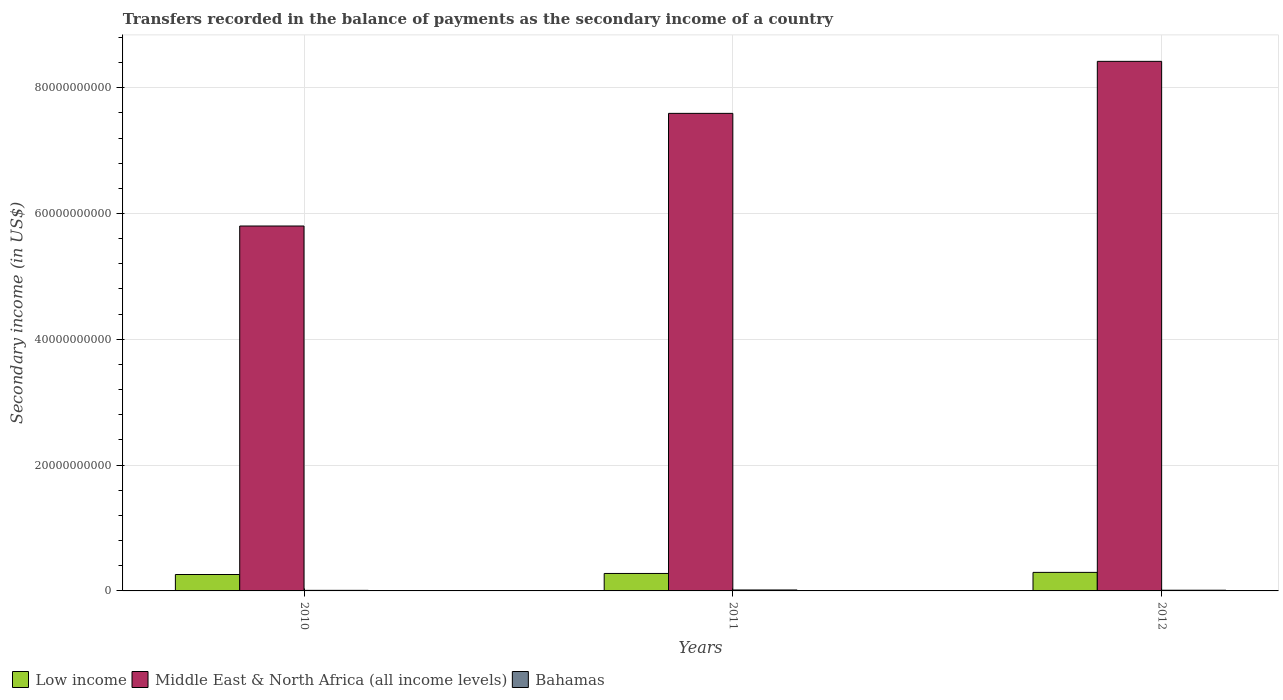How many different coloured bars are there?
Offer a very short reply. 3. Are the number of bars on each tick of the X-axis equal?
Make the answer very short. Yes. How many bars are there on the 3rd tick from the left?
Provide a succinct answer. 3. In how many cases, is the number of bars for a given year not equal to the number of legend labels?
Offer a very short reply. 0. What is the secondary income of in Low income in 2011?
Your answer should be compact. 2.78e+09. Across all years, what is the maximum secondary income of in Middle East & North Africa (all income levels)?
Provide a short and direct response. 8.42e+1. Across all years, what is the minimum secondary income of in Low income?
Your response must be concise. 2.61e+09. In which year was the secondary income of in Low income minimum?
Your answer should be compact. 2010. What is the total secondary income of in Low income in the graph?
Make the answer very short. 8.33e+09. What is the difference between the secondary income of in Low income in 2010 and that in 2011?
Your answer should be very brief. -1.67e+08. What is the difference between the secondary income of in Bahamas in 2011 and the secondary income of in Low income in 2010?
Offer a terse response. -2.46e+09. What is the average secondary income of in Bahamas per year?
Provide a short and direct response. 1.18e+08. In the year 2011, what is the difference between the secondary income of in Low income and secondary income of in Bahamas?
Offer a very short reply. 2.62e+09. In how many years, is the secondary income of in Middle East & North Africa (all income levels) greater than 60000000000 US$?
Make the answer very short. 2. What is the ratio of the secondary income of in Low income in 2011 to that in 2012?
Make the answer very short. 0.94. Is the difference between the secondary income of in Low income in 2010 and 2011 greater than the difference between the secondary income of in Bahamas in 2010 and 2011?
Ensure brevity in your answer.  No. What is the difference between the highest and the second highest secondary income of in Bahamas?
Provide a succinct answer. 3.89e+07. What is the difference between the highest and the lowest secondary income of in Middle East & North Africa (all income levels)?
Offer a terse response. 2.62e+1. Is the sum of the secondary income of in Middle East & North Africa (all income levels) in 2010 and 2011 greater than the maximum secondary income of in Bahamas across all years?
Your answer should be compact. Yes. What does the 1st bar from the right in 2010 represents?
Give a very brief answer. Bahamas. How many years are there in the graph?
Ensure brevity in your answer.  3. Are the values on the major ticks of Y-axis written in scientific E-notation?
Provide a short and direct response. No. What is the title of the graph?
Your answer should be compact. Transfers recorded in the balance of payments as the secondary income of a country. What is the label or title of the X-axis?
Your answer should be compact. Years. What is the label or title of the Y-axis?
Offer a very short reply. Secondary income (in US$). What is the Secondary income (in US$) of Low income in 2010?
Ensure brevity in your answer.  2.61e+09. What is the Secondary income (in US$) in Middle East & North Africa (all income levels) in 2010?
Keep it short and to the point. 5.80e+1. What is the Secondary income (in US$) of Bahamas in 2010?
Keep it short and to the point. 9.12e+07. What is the Secondary income (in US$) in Low income in 2011?
Provide a short and direct response. 2.78e+09. What is the Secondary income (in US$) of Middle East & North Africa (all income levels) in 2011?
Keep it short and to the point. 7.59e+1. What is the Secondary income (in US$) in Bahamas in 2011?
Ensure brevity in your answer.  1.50e+08. What is the Secondary income (in US$) of Low income in 2012?
Offer a very short reply. 2.95e+09. What is the Secondary income (in US$) of Middle East & North Africa (all income levels) in 2012?
Provide a succinct answer. 8.42e+1. What is the Secondary income (in US$) of Bahamas in 2012?
Provide a short and direct response. 1.11e+08. Across all years, what is the maximum Secondary income (in US$) of Low income?
Ensure brevity in your answer.  2.95e+09. Across all years, what is the maximum Secondary income (in US$) in Middle East & North Africa (all income levels)?
Offer a very short reply. 8.42e+1. Across all years, what is the maximum Secondary income (in US$) of Bahamas?
Make the answer very short. 1.50e+08. Across all years, what is the minimum Secondary income (in US$) in Low income?
Your answer should be very brief. 2.61e+09. Across all years, what is the minimum Secondary income (in US$) in Middle East & North Africa (all income levels)?
Offer a terse response. 5.80e+1. Across all years, what is the minimum Secondary income (in US$) of Bahamas?
Provide a succinct answer. 9.12e+07. What is the total Secondary income (in US$) of Low income in the graph?
Make the answer very short. 8.33e+09. What is the total Secondary income (in US$) of Middle East & North Africa (all income levels) in the graph?
Your answer should be very brief. 2.18e+11. What is the total Secondary income (in US$) of Bahamas in the graph?
Offer a terse response. 3.53e+08. What is the difference between the Secondary income (in US$) in Low income in 2010 and that in 2011?
Provide a succinct answer. -1.67e+08. What is the difference between the Secondary income (in US$) of Middle East & North Africa (all income levels) in 2010 and that in 2011?
Make the answer very short. -1.79e+1. What is the difference between the Secondary income (in US$) of Bahamas in 2010 and that in 2011?
Keep it short and to the point. -5.91e+07. What is the difference between the Secondary income (in US$) in Low income in 2010 and that in 2012?
Keep it short and to the point. -3.38e+08. What is the difference between the Secondary income (in US$) in Middle East & North Africa (all income levels) in 2010 and that in 2012?
Your answer should be compact. -2.62e+1. What is the difference between the Secondary income (in US$) of Bahamas in 2010 and that in 2012?
Make the answer very short. -2.02e+07. What is the difference between the Secondary income (in US$) of Low income in 2011 and that in 2012?
Provide a short and direct response. -1.72e+08. What is the difference between the Secondary income (in US$) of Middle East & North Africa (all income levels) in 2011 and that in 2012?
Offer a terse response. -8.27e+09. What is the difference between the Secondary income (in US$) in Bahamas in 2011 and that in 2012?
Your answer should be very brief. 3.89e+07. What is the difference between the Secondary income (in US$) in Low income in 2010 and the Secondary income (in US$) in Middle East & North Africa (all income levels) in 2011?
Your answer should be compact. -7.33e+1. What is the difference between the Secondary income (in US$) of Low income in 2010 and the Secondary income (in US$) of Bahamas in 2011?
Give a very brief answer. 2.46e+09. What is the difference between the Secondary income (in US$) in Middle East & North Africa (all income levels) in 2010 and the Secondary income (in US$) in Bahamas in 2011?
Your response must be concise. 5.79e+1. What is the difference between the Secondary income (in US$) of Low income in 2010 and the Secondary income (in US$) of Middle East & North Africa (all income levels) in 2012?
Make the answer very short. -8.16e+1. What is the difference between the Secondary income (in US$) in Low income in 2010 and the Secondary income (in US$) in Bahamas in 2012?
Provide a succinct answer. 2.50e+09. What is the difference between the Secondary income (in US$) of Middle East & North Africa (all income levels) in 2010 and the Secondary income (in US$) of Bahamas in 2012?
Make the answer very short. 5.79e+1. What is the difference between the Secondary income (in US$) of Low income in 2011 and the Secondary income (in US$) of Middle East & North Africa (all income levels) in 2012?
Your answer should be compact. -8.14e+1. What is the difference between the Secondary income (in US$) of Low income in 2011 and the Secondary income (in US$) of Bahamas in 2012?
Your answer should be compact. 2.66e+09. What is the difference between the Secondary income (in US$) of Middle East & North Africa (all income levels) in 2011 and the Secondary income (in US$) of Bahamas in 2012?
Keep it short and to the point. 7.58e+1. What is the average Secondary income (in US$) of Low income per year?
Provide a succinct answer. 2.78e+09. What is the average Secondary income (in US$) of Middle East & North Africa (all income levels) per year?
Your answer should be very brief. 7.27e+1. What is the average Secondary income (in US$) in Bahamas per year?
Offer a very short reply. 1.18e+08. In the year 2010, what is the difference between the Secondary income (in US$) of Low income and Secondary income (in US$) of Middle East & North Africa (all income levels)?
Offer a terse response. -5.54e+1. In the year 2010, what is the difference between the Secondary income (in US$) in Low income and Secondary income (in US$) in Bahamas?
Give a very brief answer. 2.52e+09. In the year 2010, what is the difference between the Secondary income (in US$) of Middle East & North Africa (all income levels) and Secondary income (in US$) of Bahamas?
Make the answer very short. 5.79e+1. In the year 2011, what is the difference between the Secondary income (in US$) in Low income and Secondary income (in US$) in Middle East & North Africa (all income levels)?
Ensure brevity in your answer.  -7.31e+1. In the year 2011, what is the difference between the Secondary income (in US$) in Low income and Secondary income (in US$) in Bahamas?
Offer a terse response. 2.62e+09. In the year 2011, what is the difference between the Secondary income (in US$) of Middle East & North Africa (all income levels) and Secondary income (in US$) of Bahamas?
Ensure brevity in your answer.  7.58e+1. In the year 2012, what is the difference between the Secondary income (in US$) in Low income and Secondary income (in US$) in Middle East & North Africa (all income levels)?
Provide a short and direct response. -8.12e+1. In the year 2012, what is the difference between the Secondary income (in US$) of Low income and Secondary income (in US$) of Bahamas?
Offer a very short reply. 2.84e+09. In the year 2012, what is the difference between the Secondary income (in US$) of Middle East & North Africa (all income levels) and Secondary income (in US$) of Bahamas?
Your answer should be compact. 8.41e+1. What is the ratio of the Secondary income (in US$) of Low income in 2010 to that in 2011?
Offer a very short reply. 0.94. What is the ratio of the Secondary income (in US$) in Middle East & North Africa (all income levels) in 2010 to that in 2011?
Make the answer very short. 0.76. What is the ratio of the Secondary income (in US$) in Bahamas in 2010 to that in 2011?
Offer a terse response. 0.61. What is the ratio of the Secondary income (in US$) of Low income in 2010 to that in 2012?
Provide a short and direct response. 0.89. What is the ratio of the Secondary income (in US$) in Middle East & North Africa (all income levels) in 2010 to that in 2012?
Your answer should be compact. 0.69. What is the ratio of the Secondary income (in US$) of Bahamas in 2010 to that in 2012?
Provide a succinct answer. 0.82. What is the ratio of the Secondary income (in US$) in Low income in 2011 to that in 2012?
Your response must be concise. 0.94. What is the ratio of the Secondary income (in US$) in Middle East & North Africa (all income levels) in 2011 to that in 2012?
Make the answer very short. 0.9. What is the ratio of the Secondary income (in US$) in Bahamas in 2011 to that in 2012?
Give a very brief answer. 1.35. What is the difference between the highest and the second highest Secondary income (in US$) of Low income?
Give a very brief answer. 1.72e+08. What is the difference between the highest and the second highest Secondary income (in US$) in Middle East & North Africa (all income levels)?
Provide a short and direct response. 8.27e+09. What is the difference between the highest and the second highest Secondary income (in US$) of Bahamas?
Your answer should be compact. 3.89e+07. What is the difference between the highest and the lowest Secondary income (in US$) of Low income?
Give a very brief answer. 3.38e+08. What is the difference between the highest and the lowest Secondary income (in US$) in Middle East & North Africa (all income levels)?
Offer a terse response. 2.62e+1. What is the difference between the highest and the lowest Secondary income (in US$) in Bahamas?
Give a very brief answer. 5.91e+07. 